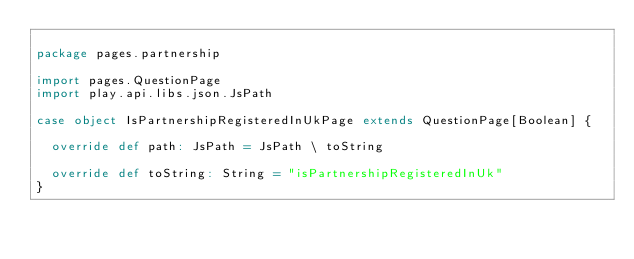Convert code to text. <code><loc_0><loc_0><loc_500><loc_500><_Scala_>
package pages.partnership

import pages.QuestionPage
import play.api.libs.json.JsPath

case object IsPartnershipRegisteredInUkPage extends QuestionPage[Boolean] {

  override def path: JsPath = JsPath \ toString

  override def toString: String = "isPartnershipRegisteredInUk"
}
</code> 